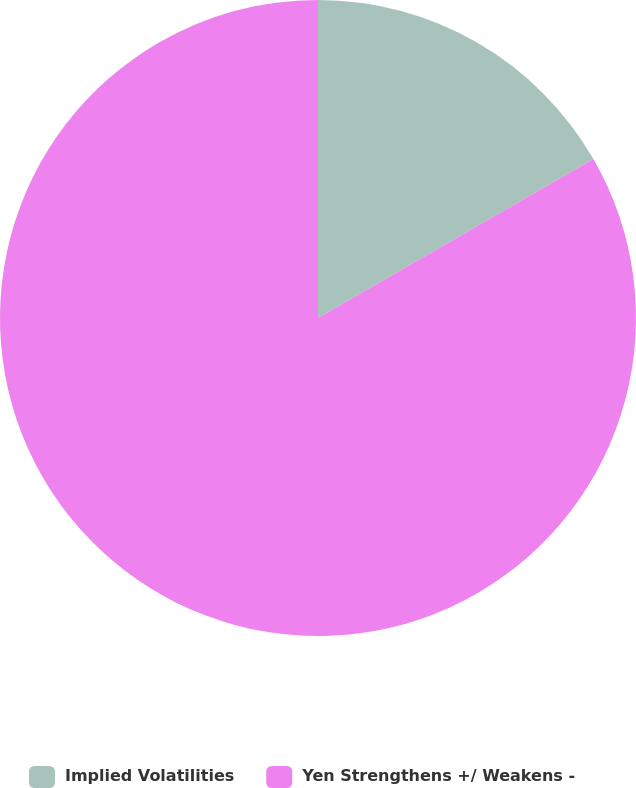<chart> <loc_0><loc_0><loc_500><loc_500><pie_chart><fcel>Implied Volatilities<fcel>Yen Strengthens +/ Weakens -<nl><fcel>16.67%<fcel>83.33%<nl></chart> 